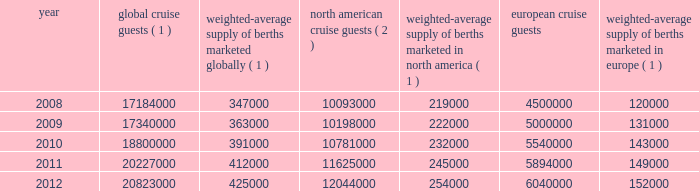Result of the effects of the costa concordia incident and the continued instability in the european eco- nomic landscape .
However , we continue to believe in the long term growth potential of this market .
We estimate that europe was served by 102 ships with approximately 108000 berths at the beginning of 2008 and by 117 ships with approximately 156000 berths at the end of 2012 .
There are approximately 9 ships with an estimated 25000 berths that are expected to be placed in service in the european cruise market between 2013 and 2017 .
The table details the growth in the global , north american and european cruise markets in terms of cruise guests and estimated weighted-average berths over the past five years : global cruise guests ( 1 ) weighted-average supply of berths marketed globally ( 1 ) north american cruise guests ( 2 ) weighted-average supply of berths marketed in north america ( 1 ) european cruise guests weighted-average supply of berths marketed in europe ( 1 ) .
( 1 ) source : our estimates of the number of global cruise guests , and the weighted-average supply of berths marketed globally , in north america and europe are based on a combination of data that we obtain from various publicly available cruise industry trade information sources including seatrade insider and cruise line international association ( 201cclia 201d ) .
In addition , our estimates incorporate our own statistical analysis utilizing the same publicly available cruise industry data as a base .
( 2 ) source : cruise line international association based on cruise guests carried for at least two consecutive nights for years 2008 through 2011 .
Year 2012 amounts represent our estimates ( see number 1 above ) .
( 3 ) source : clia europe , formerly european cruise council , for years 2008 through 2011 .
Year 2012 amounts represent our estimates ( see number 1 above ) .
Other markets in addition to expected industry growth in north america and europe as discussed above , we expect the asia/pacific region to demonstrate an even higher growth rate in the near term , although it will continue to represent a relatively small sector compared to north america and europe .
Competition we compete with a number of cruise lines .
Our princi- pal competitors are carnival corporation & plc , which owns , among others , aida cruises , carnival cruise lines , costa cruises , cunard line , holland america line , iberocruceros , p&o cruises and princess cruises ; disney cruise line ; msc cruises ; norwegian cruise line and oceania cruises .
Cruise lines compete with other vacation alternatives such as land-based resort hotels and sightseeing destinations for consumers 2019 leisure time .
Demand for such activities is influenced by political and general economic conditions .
Com- panies within the vacation market are dependent on consumer discretionary spending .
Operating strategies our principal operating strategies are to : 2022 protect the health , safety and security of our guests and employees and protect the environment in which our vessels and organization operate , 2022 strengthen and support our human capital in order to better serve our global guest base and grow our business , 2022 further strengthen our consumer engagement in order to enhance our revenues , 2022 increase the awareness and market penetration of our brands globally , 2022 focus on cost efficiency , manage our operating expenditures and ensure adequate cash and liquid- ity , with the overall goal of maximizing our return on invested capital and long-term shareholder value , 2022 strategically invest in our fleet through the revit ad alization of existing ships and the transfer of key innovations across each brand , while prudently expanding our fleet with the new state-of-the-art cruise ships recently delivered and on order , 2022 capitalize on the portability and flexibility of our ships by deploying them into those markets and itineraries that provide opportunities to optimize returns , while continuing our focus on existing key markets , 2022 further enhance our technological capabilities to service customer preferences and expectations in an innovative manner , while supporting our strategic focus on profitability , and part i 0494.indd 13 3/27/13 12:52 pm .
What is the anticipated percentage increase in the berths for the european cruise market from 2013 to 2017? 
Computations: (25000 / 156000)
Answer: 0.16026. 